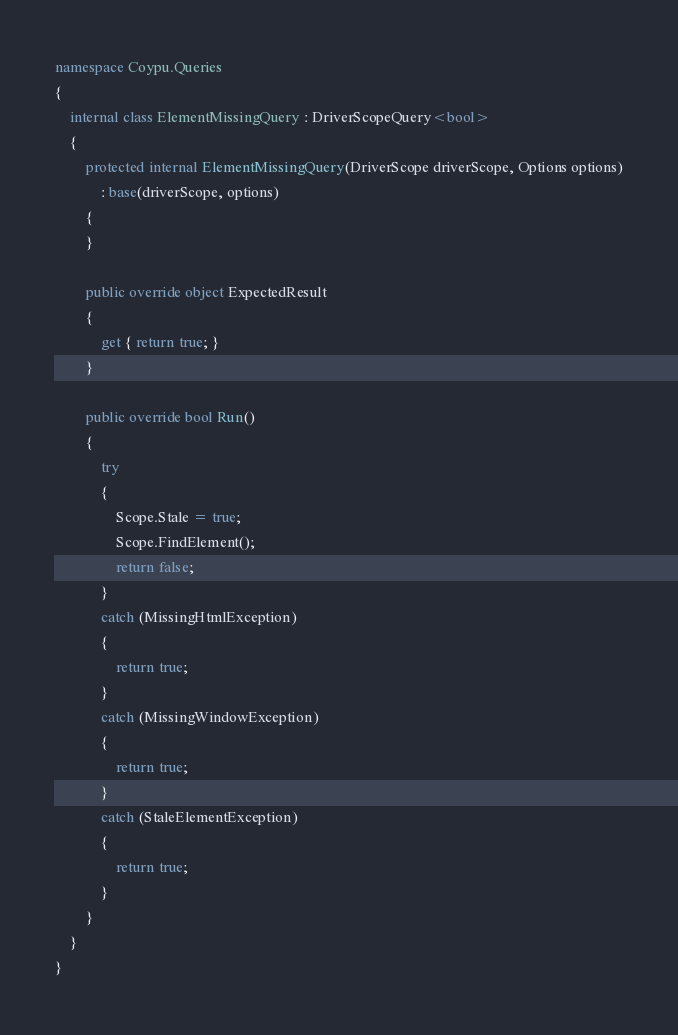Convert code to text. <code><loc_0><loc_0><loc_500><loc_500><_C#_>namespace Coypu.Queries
{
    internal class ElementMissingQuery : DriverScopeQuery<bool>
    {
        protected internal ElementMissingQuery(DriverScope driverScope, Options options)
            : base(driverScope, options)
        {
        }

        public override object ExpectedResult
        {
            get { return true; }
        }

        public override bool Run()
        {
            try
            {
                Scope.Stale = true;
                Scope.FindElement();
                return false;
            }
            catch (MissingHtmlException)
            {
                return true;
            }
            catch (MissingWindowException)
            {
                return true;
            }
            catch (StaleElementException)
            {
                return true;
            }
        }
    }
}</code> 